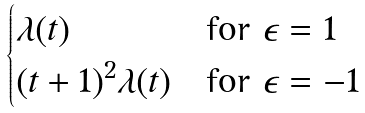Convert formula to latex. <formula><loc_0><loc_0><loc_500><loc_500>\begin{cases} \lambda ( t ) & \text {for } \epsilon = 1 \\ ( t + 1 ) ^ { 2 } \lambda ( t ) & \text {for } \epsilon = - 1 \end{cases}</formula> 